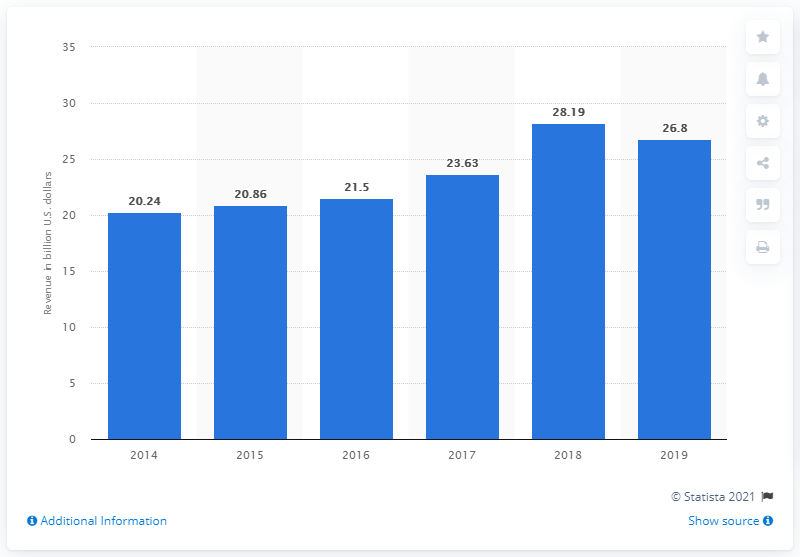Specify some key components in this picture. MetLife's revenue from premiums written in the U.S. in 2019 was $26.8 million. 